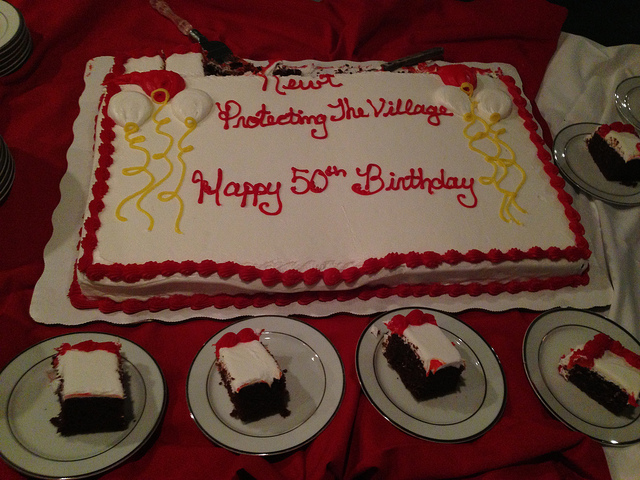<image>What kind of math is this? I don't know, there seems to be no math in the picture. Who will be missed? I am not sure who will be missed. It could be Newt, John, or the birthday cake. Will these foods likely be assembled into a sandwich? No, these foods will likely not be assembled into a sandwich. What kind of math is this? It is unanswerable what kind of math is this. Will these foods likely be assembled into a sandwich? It is unanswerable whether these foods will likely be assembled into a sandwich. Who will be missed? I don't know who will be missed. It could be nobody, the birthday cake, John, or the village. 